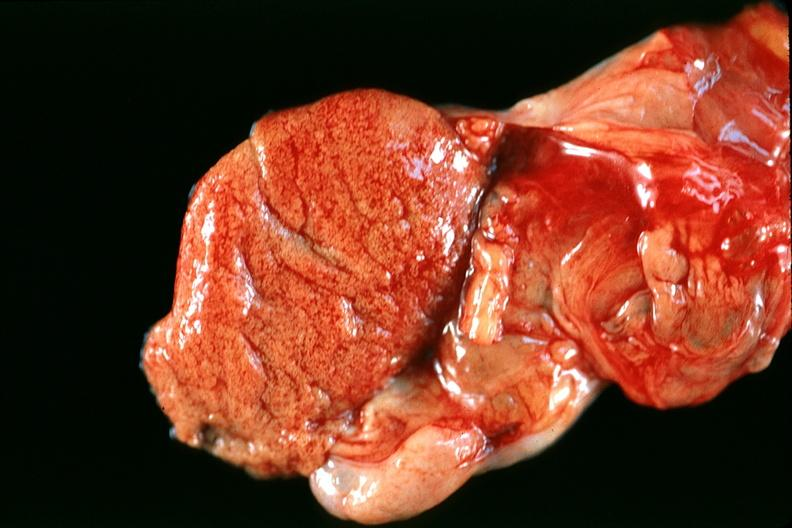does this image show normal testes?
Answer the question using a single word or phrase. Yes 